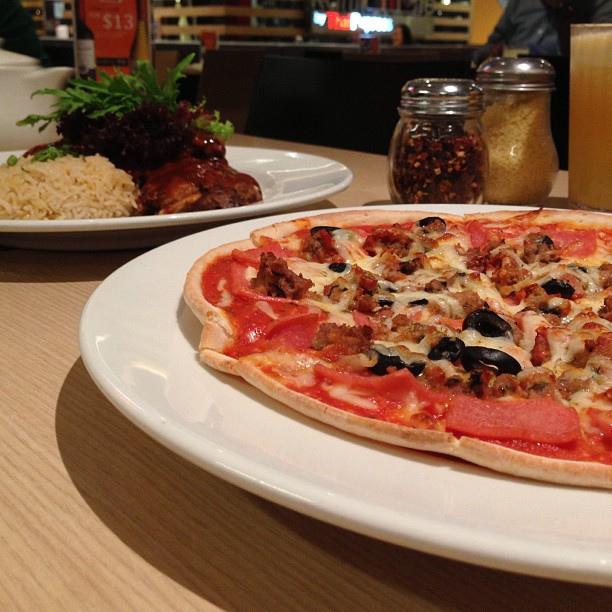Does the pizza have pepperoni?
Write a very short answer. Yes. Is this a picture of a thick crust pizza?
Concise answer only. No. Are there other foods on the table?
Concise answer only. Yes. 